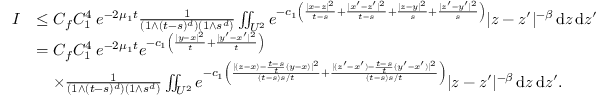<formula> <loc_0><loc_0><loc_500><loc_500>\begin{array} { r l } { I } & { \leq C _ { f } C _ { 1 } ^ { 4 } \, e ^ { - 2 \mu _ { 1 } t } \frac { 1 } { ( 1 \wedge ( t - s ) ^ { d } ) ( 1 \wedge s ^ { d } ) } \iint _ { U ^ { 2 } } e ^ { - c _ { 1 } \left ( \frac { | x - z | ^ { 2 } } { t - s } + \frac { | x ^ { \prime } - z ^ { \prime } | ^ { 2 } } { t - s } + \frac { | z - y | ^ { 2 } } { s } + \frac { | z ^ { \prime } - y ^ { \prime } | ^ { 2 } } { s } \right ) } | z - z ^ { \prime } | ^ { - \beta } \, { d } z \, { d } z ^ { \prime } } \\ & { = C _ { f } C _ { 1 } ^ { 4 } \, e ^ { - 2 \mu _ { 1 } t } e ^ { - c _ { 1 } \left ( \frac { | y - x | ^ { 2 } } { t } + \frac { | y ^ { \prime } - x ^ { \prime } | ^ { 2 } } { t } \right ) } } \\ & { \quad \times \frac { 1 } { ( 1 \wedge ( t - s ) ^ { d } ) ( 1 \wedge s ^ { d } ) } \iint _ { U ^ { 2 } } e ^ { - c _ { 1 } \left ( \frac { | ( z - x ) - \frac { t - s } { t } ( y - x ) | ^ { 2 } } { ( t - s ) s / t } + \frac { | ( z ^ { \prime } - x ^ { \prime } ) - \frac { t - s } { t } ( y ^ { \prime } - x ^ { \prime } ) | ^ { 2 } } { ( t - s ) s / t } \right ) } | z - z ^ { \prime } | ^ { - \beta } \, { d } z \, { d } z ^ { \prime } . } \end{array}</formula> 